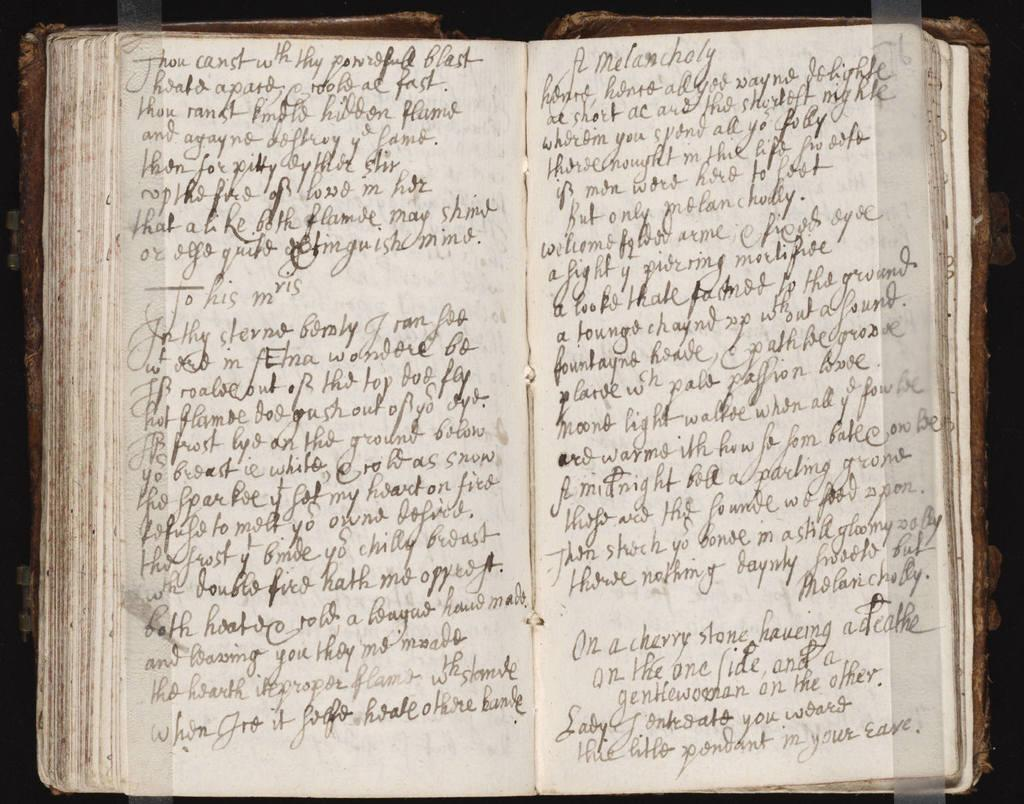<image>
Relay a brief, clear account of the picture shown. Opened pages from an illegibly handwritten journal from the time when "thou' is used. 